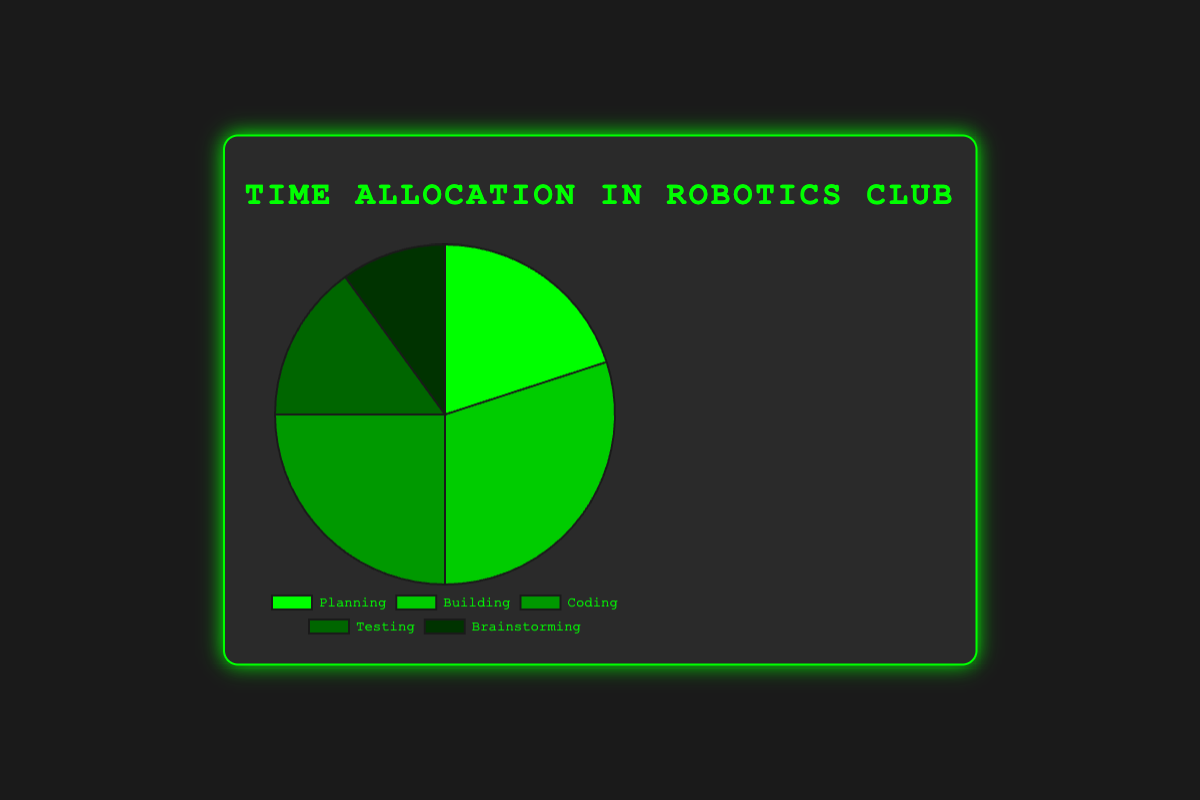Which segment occupies the most time in the meeting? The segment with the highest percentage in the pie chart occupies the most time. By visual inspection, the "Building" segment occupies the most time.
Answer: Building Which segment occupies the least time in the meeting? The segment with the smallest percentage in the pie chart occupies the least time. By visual inspection, the "Brainstorming" segment occupies the least time.
Answer: Brainstorming What is the total percentage of time spent on Planning and Coding combined? To find the combined percentage, add the percentages for Planning (20%) and Coding (25%). This calculation gives 20% + 25% = 45%.
Answer: 45% How does the time allocated to Testing compare to Planning? Look at the percentages for Testing (15%) and Planning (20%). Testing is 5% less than Planning.
Answer: Testing is 5% less than Planning Which segment has a darker shade of green, Coding or Brainstorming? Visually compare the shades of green for the segments. The segment for Coding has a darker shade of green compared to Brainstorming.
Answer: Coding Is the time spent on Brainstorming more than half of the time spent on Building? The percentage of time spent on Brainstorming is 10% and on Building is 30%. More than half of Building would be 15%, therefore Brainstorming is less than half of Building.
Answer: No, Brainstorming is less than half of Building If Planning and Brainstorming were combined into a single segment, what would be the percentage of this new segment? Combine the percentages for Planning (20%) and Brainstorming (10%) to get 20% + 10% = 30%.
Answer: 30% How much more time is spent on Coding as compared to Testing? Compare the percentages: Coding (25%) and Testing (15%). The difference is 25% - 15% = 10%.
Answer: 10% What is the average percentage of the time spent on Planning, Coding, and Testing? Add the percentages for Planning (20%), Coding (25%), and Testing (15%), and then divide by 3. This calculation is (20% + 25% + 15%) / 3 = 60% / 3 = 20%.
Answer: 20% 